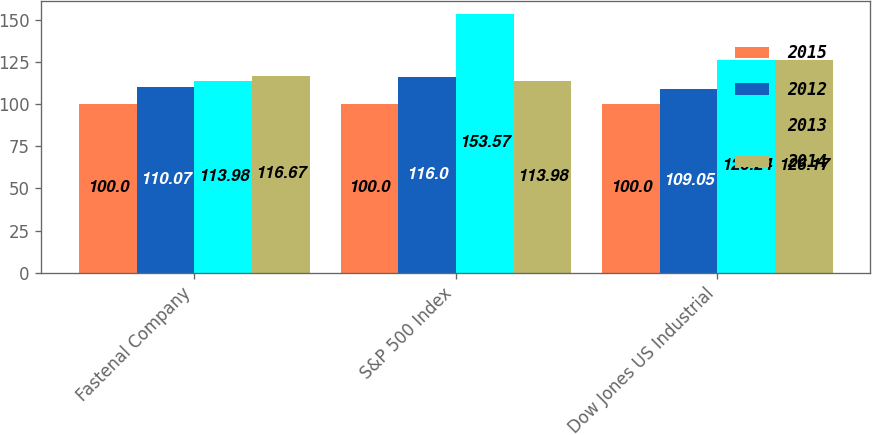Convert chart to OTSL. <chart><loc_0><loc_0><loc_500><loc_500><stacked_bar_chart><ecel><fcel>Fastenal Company<fcel>S&P 500 Index<fcel>Dow Jones US Industrial<nl><fcel>2015<fcel>100<fcel>100<fcel>100<nl><fcel>2012<fcel>110.07<fcel>116<fcel>109.05<nl><fcel>2013<fcel>113.98<fcel>153.57<fcel>126.24<nl><fcel>2014<fcel>116.67<fcel>113.98<fcel>126.17<nl></chart> 